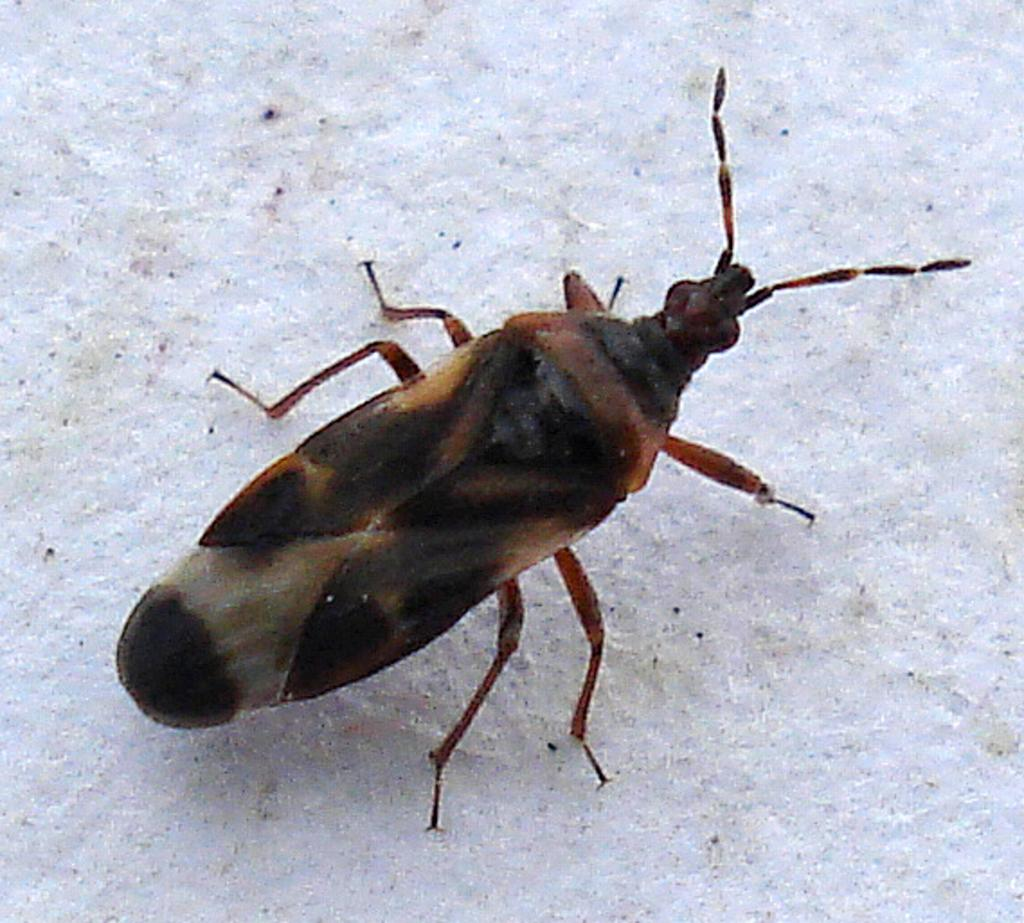What type of creature can be seen in the image? There is an insect in the image. What is the color of the surface where the insect is located? The insect is on a white color surface. What type of farm equipment is visible in the image? There is no farm equipment present in the image; it features an insect on a white surface. Can you describe the motion of the rabbit in the image? There is no rabbit present in the image, so it is not possible to describe its motion. 